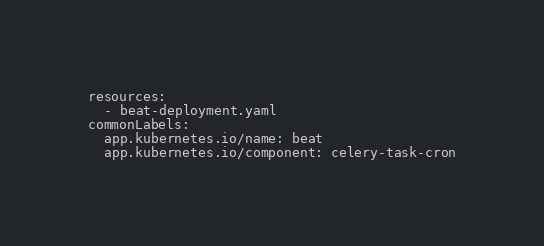<code> <loc_0><loc_0><loc_500><loc_500><_YAML_>resources:
  - beat-deployment.yaml
commonLabels:
  app.kubernetes.io/name: beat
  app.kubernetes.io/component: celery-task-cron</code> 